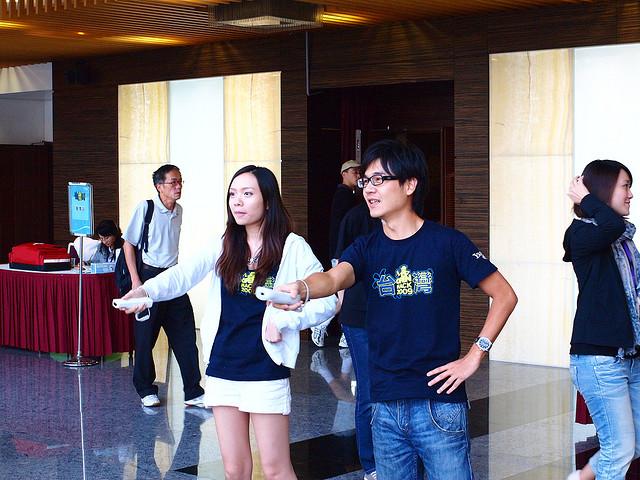What nationality do they look?
Answer briefly. Asian. What are they playing with?
Answer briefly. Wii. Can these pointers control a device?
Concise answer only. Yes. 